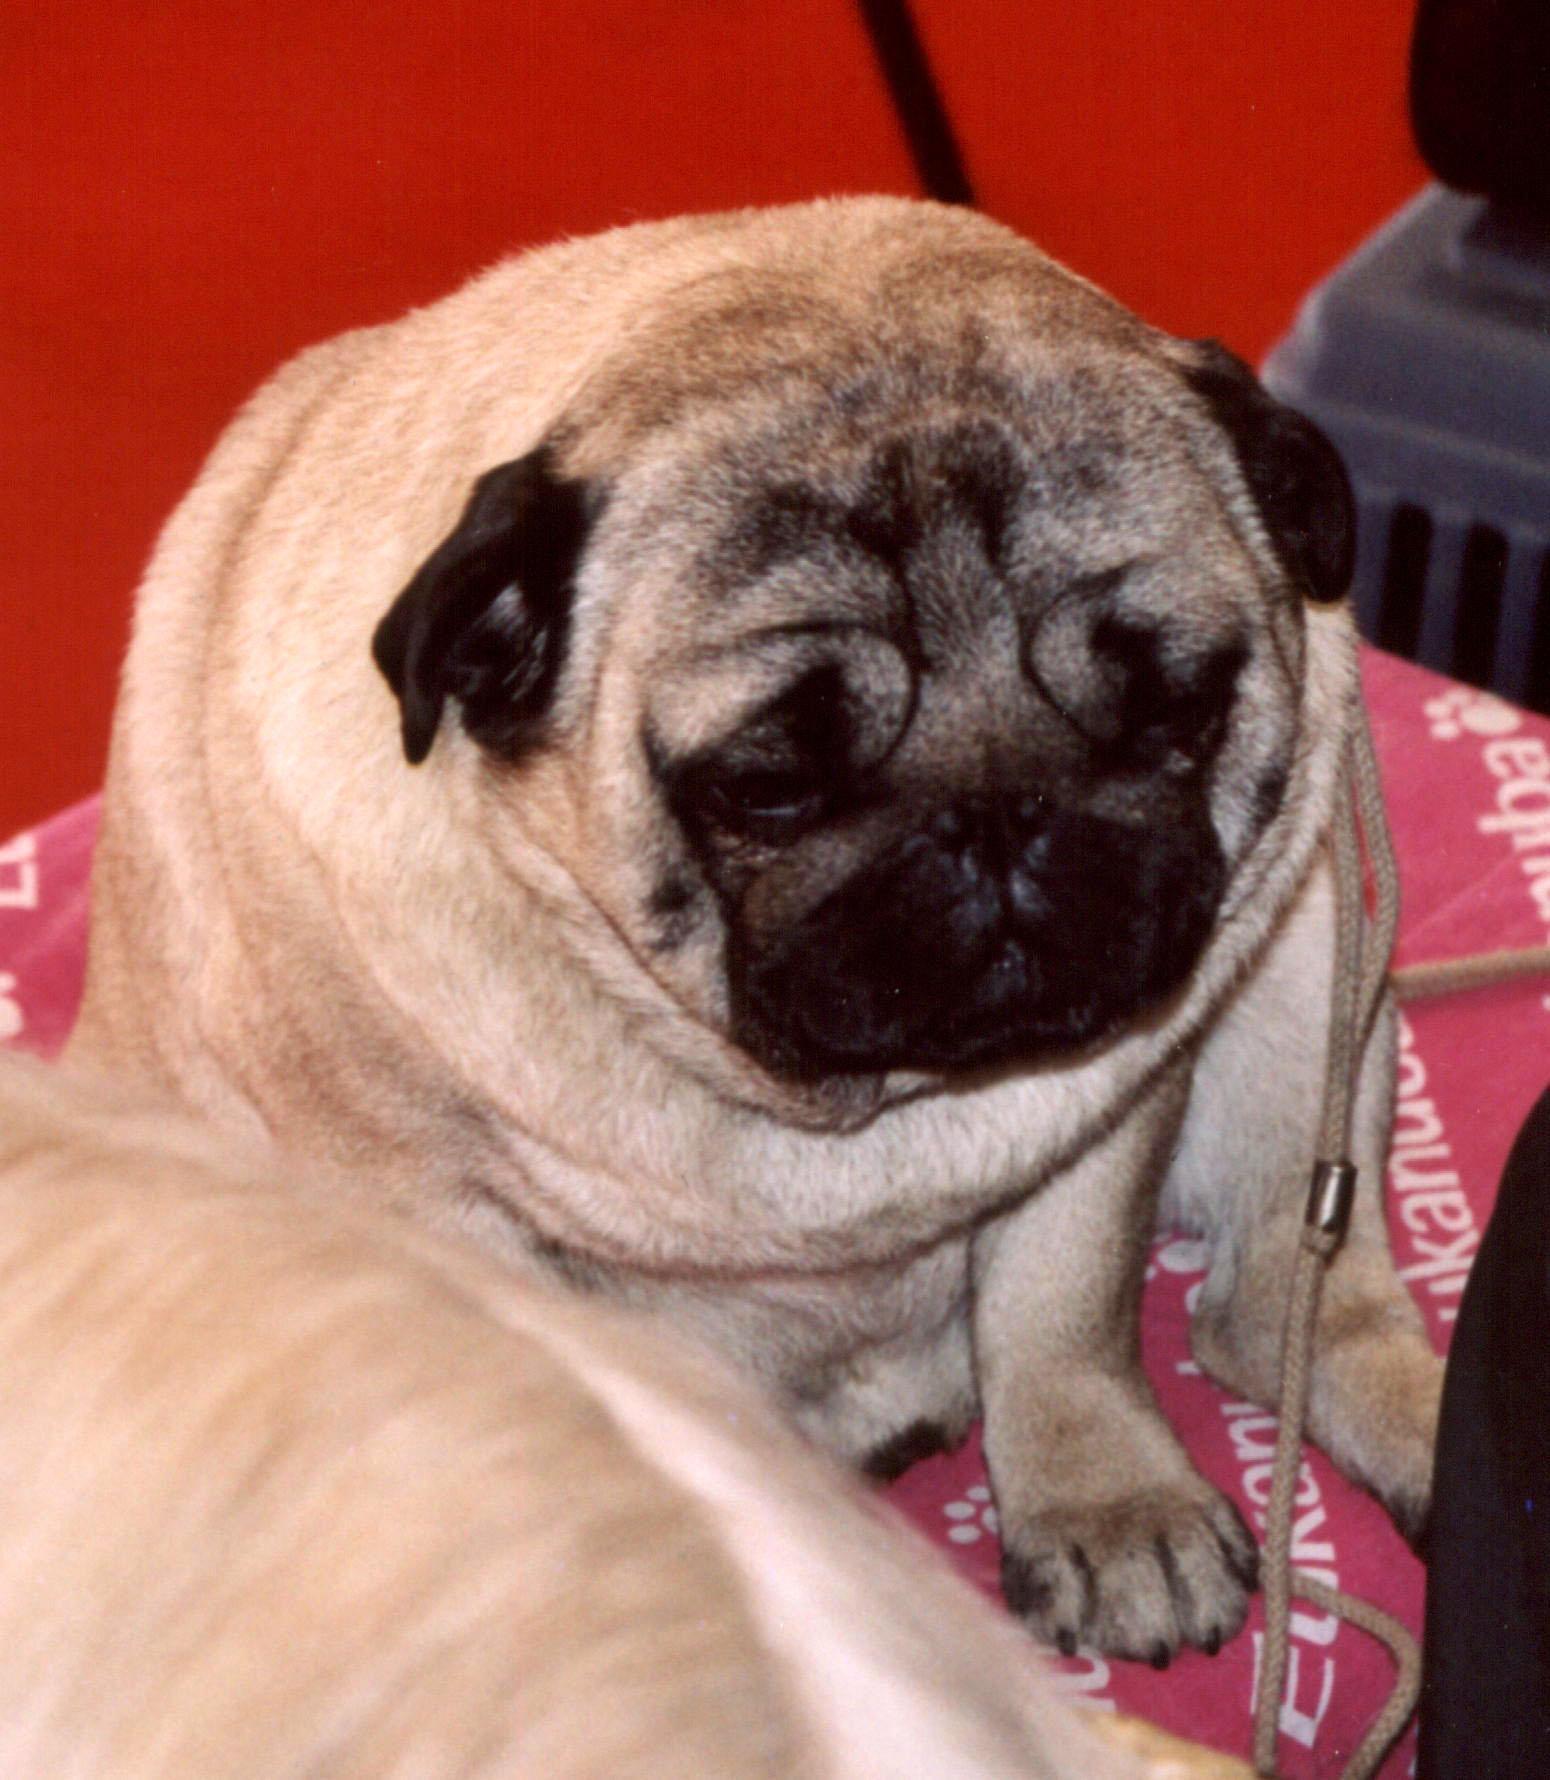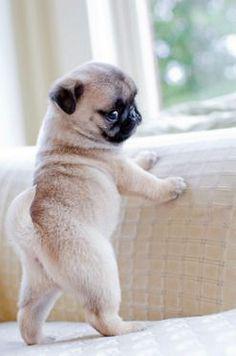The first image is the image on the left, the second image is the image on the right. Examine the images to the left and right. Is the description "The dog in the image on the left is on a pink piece of material." accurate? Answer yes or no. Yes. 